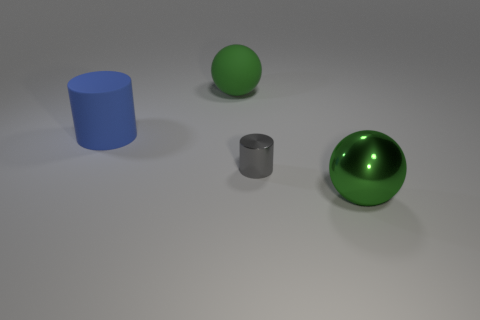Add 3 gray metal cylinders. How many objects exist? 7 Subtract all green metallic spheres. Subtract all tiny red metallic spheres. How many objects are left? 3 Add 4 tiny cylinders. How many tiny cylinders are left? 5 Add 4 matte things. How many matte things exist? 6 Subtract 0 purple cubes. How many objects are left? 4 